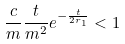Convert formula to latex. <formula><loc_0><loc_0><loc_500><loc_500>\frac { c } { m } \frac { t } { m ^ { 2 } } e ^ { - \frac { t } { 2 r _ { 1 } } } < 1</formula> 